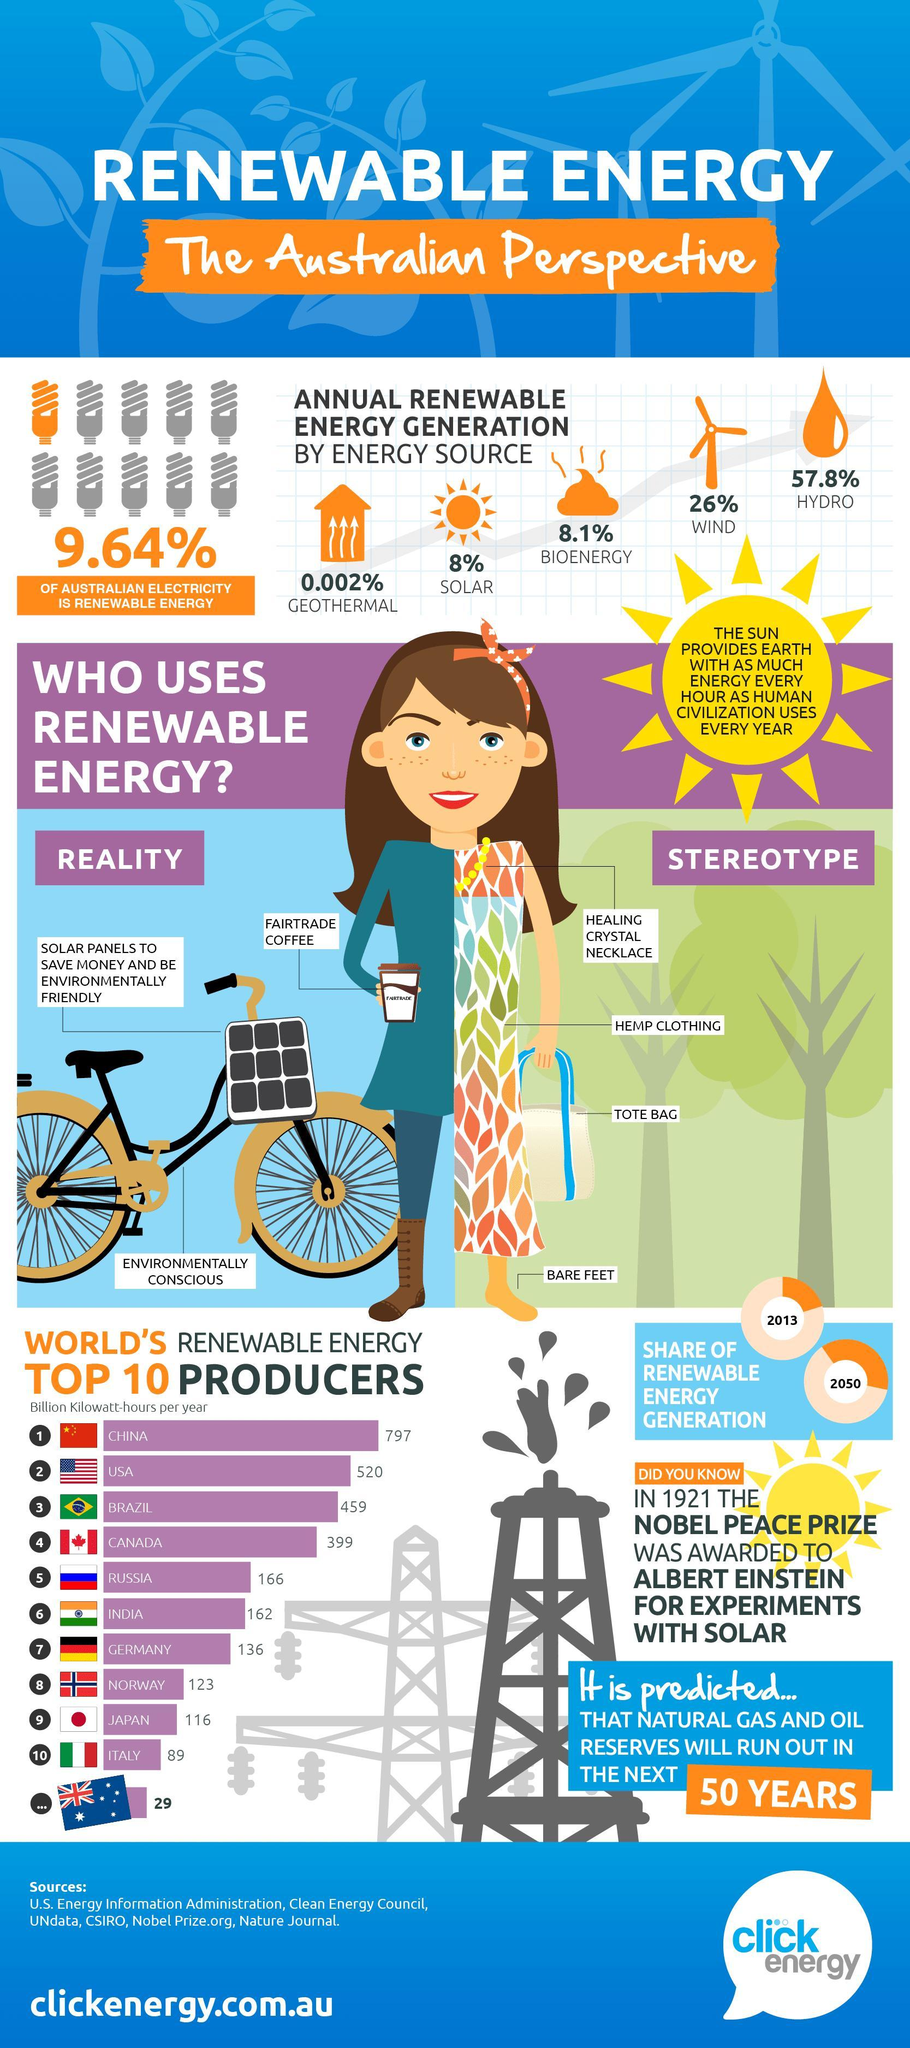Which country is the world's second largest producer of renewable energy among the given countries?
Answer the question with a short phrase. USA How much is the Indian renewable energy potential (in billion kilowatt-hours per year)? 162 What percentage of Australia's annual renewable energy is from solar? 8% What amount of renewable energy (in billion kilowatt-hours per year) is produced by the USA? 520 What is the main source of renewable energy in Australia? HYDRO What percent of Australian electricity is non renewable energy? 90.36% Which country is the world's top producer of the renewable energy among the given countries? CHINA Which energy source contributes the least to Australia's annual renewable energy? GEOTHERMAL 